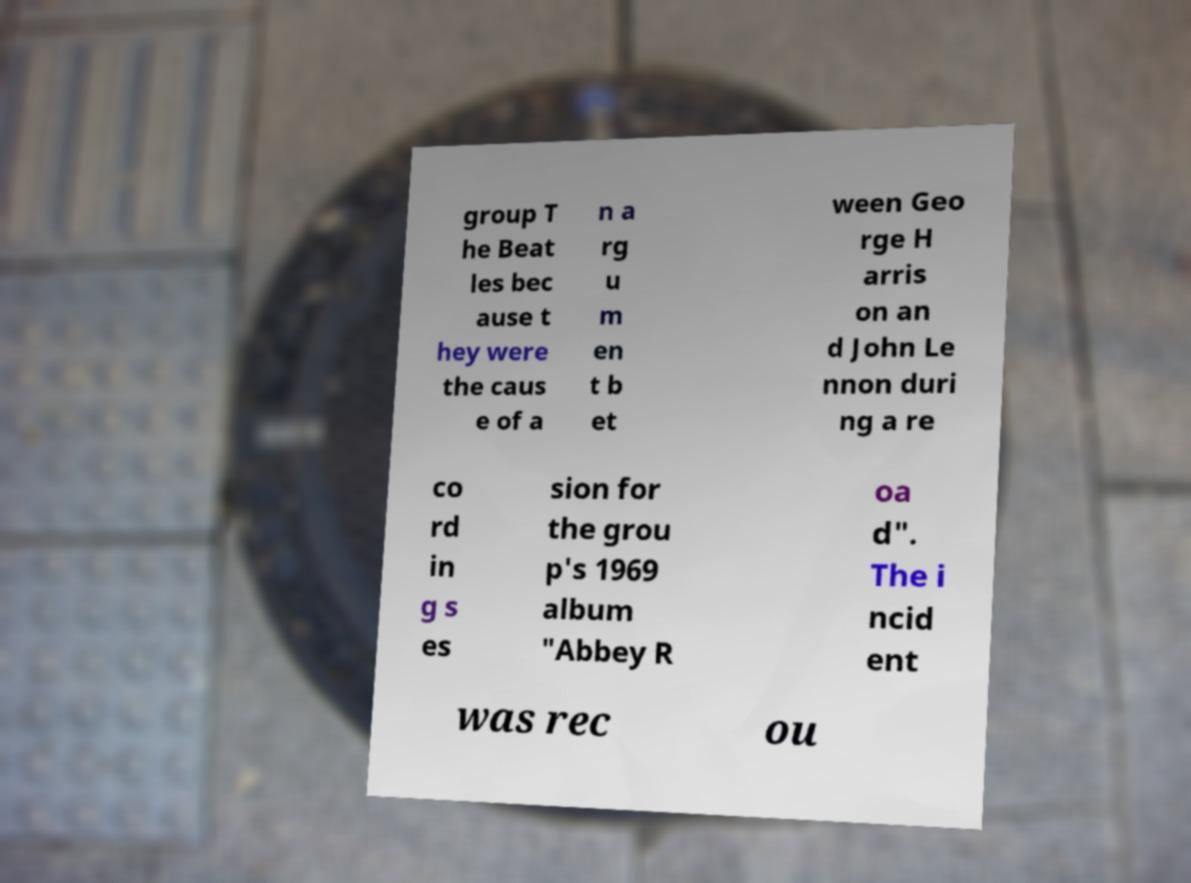I need the written content from this picture converted into text. Can you do that? group T he Beat les bec ause t hey were the caus e of a n a rg u m en t b et ween Geo rge H arris on an d John Le nnon duri ng a re co rd in g s es sion for the grou p's 1969 album "Abbey R oa d". The i ncid ent was rec ou 